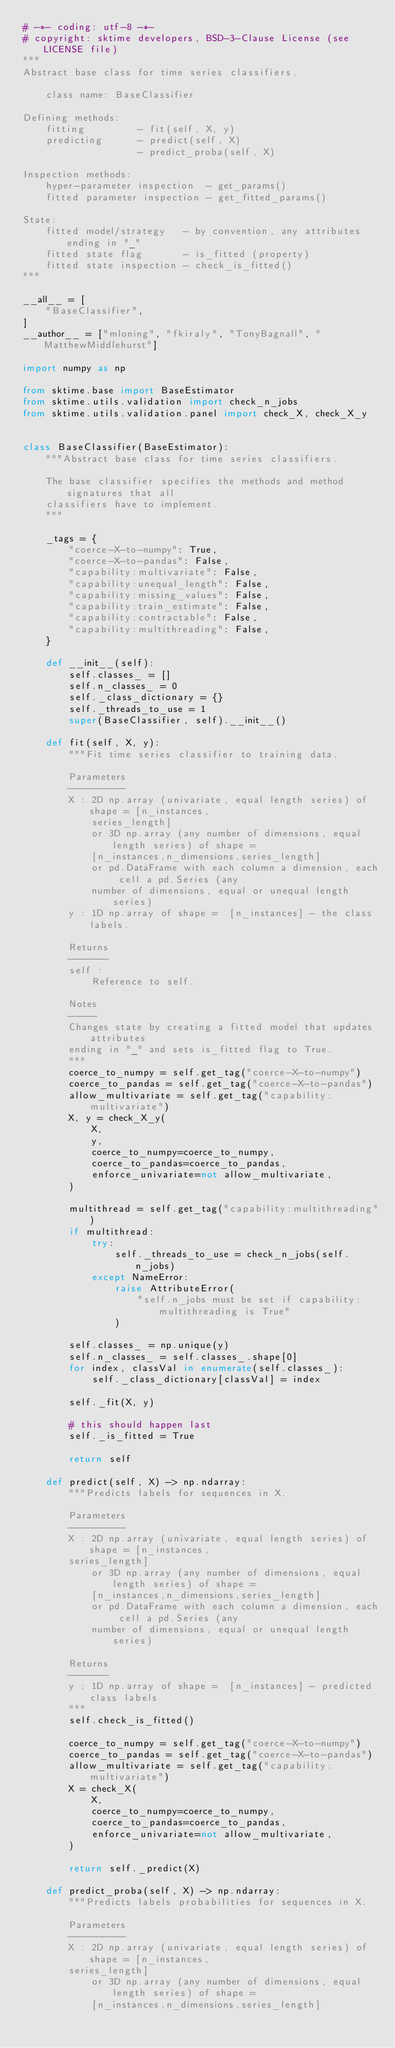<code> <loc_0><loc_0><loc_500><loc_500><_Python_># -*- coding: utf-8 -*-
# copyright: sktime developers, BSD-3-Clause License (see LICENSE file)
"""
Abstract base class for time series classifiers.

    class name: BaseClassifier

Defining methods:
    fitting         - fit(self, X, y)
    predicting      - predict(self, X)
                    - predict_proba(self, X)

Inspection methods:
    hyper-parameter inspection  - get_params()
    fitted parameter inspection - get_fitted_params()

State:
    fitted model/strategy   - by convention, any attributes ending in "_"
    fitted state flag       - is_fitted (property)
    fitted state inspection - check_is_fitted()
"""

__all__ = [
    "BaseClassifier",
]
__author__ = ["mloning", "fkiraly", "TonyBagnall", "MatthewMiddlehurst"]

import numpy as np

from sktime.base import BaseEstimator
from sktime.utils.validation import check_n_jobs
from sktime.utils.validation.panel import check_X, check_X_y


class BaseClassifier(BaseEstimator):
    """Abstract base class for time series classifiers.

    The base classifier specifies the methods and method signatures that all
    classifiers have to implement.
    """

    _tags = {
        "coerce-X-to-numpy": True,
        "coerce-X-to-pandas": False,
        "capability:multivariate": False,
        "capability:unequal_length": False,
        "capability:missing_values": False,
        "capability:train_estimate": False,
        "capability:contractable": False,
        "capability:multithreading": False,
    }

    def __init__(self):
        self.classes_ = []
        self.n_classes_ = 0
        self._class_dictionary = {}
        self._threads_to_use = 1
        super(BaseClassifier, self).__init__()

    def fit(self, X, y):
        """Fit time series classifier to training data.

        Parameters
        ----------
        X : 2D np.array (univariate, equal length series) of shape = [n_instances,
            series_length]
            or 3D np.array (any number of dimensions, equal length series) of shape =
            [n_instances,n_dimensions,series_length]
            or pd.DataFrame with each column a dimension, each cell a pd.Series (any
            number of dimensions, equal or unequal length series)
        y : 1D np.array of shape =  [n_instances] - the class labels.

        Returns
        -------
        self :
            Reference to self.

        Notes
        -----
        Changes state by creating a fitted model that updates attributes
        ending in "_" and sets is_fitted flag to True.
        """
        coerce_to_numpy = self.get_tag("coerce-X-to-numpy")
        coerce_to_pandas = self.get_tag("coerce-X-to-pandas")
        allow_multivariate = self.get_tag("capability:multivariate")
        X, y = check_X_y(
            X,
            y,
            coerce_to_numpy=coerce_to_numpy,
            coerce_to_pandas=coerce_to_pandas,
            enforce_univariate=not allow_multivariate,
        )

        multithread = self.get_tag("capability:multithreading")
        if multithread:
            try:
                self._threads_to_use = check_n_jobs(self.n_jobs)
            except NameError:
                raise AttributeError(
                    "self.n_jobs must be set if capability:multithreading is True"
                )

        self.classes_ = np.unique(y)
        self.n_classes_ = self.classes_.shape[0]
        for index, classVal in enumerate(self.classes_):
            self._class_dictionary[classVal] = index

        self._fit(X, y)

        # this should happen last
        self._is_fitted = True

        return self

    def predict(self, X) -> np.ndarray:
        """Predicts labels for sequences in X.

        Parameters
        ----------
        X : 2D np.array (univariate, equal length series) of shape = [n_instances,
        series_length]
            or 3D np.array (any number of dimensions, equal length series) of shape =
            [n_instances,n_dimensions,series_length]
            or pd.DataFrame with each column a dimension, each cell a pd.Series (any
            number of dimensions, equal or unequal length series)

        Returns
        -------
        y : 1D np.array of shape =  [n_instances] - predicted class labels
        """
        self.check_is_fitted()

        coerce_to_numpy = self.get_tag("coerce-X-to-numpy")
        coerce_to_pandas = self.get_tag("coerce-X-to-pandas")
        allow_multivariate = self.get_tag("capability:multivariate")
        X = check_X(
            X,
            coerce_to_numpy=coerce_to_numpy,
            coerce_to_pandas=coerce_to_pandas,
            enforce_univariate=not allow_multivariate,
        )

        return self._predict(X)

    def predict_proba(self, X) -> np.ndarray:
        """Predicts labels probabilities for sequences in X.

        Parameters
        ----------
        X : 2D np.array (univariate, equal length series) of shape = [n_instances,
        series_length]
            or 3D np.array (any number of dimensions, equal length series) of shape =
            [n_instances,n_dimensions,series_length]</code> 